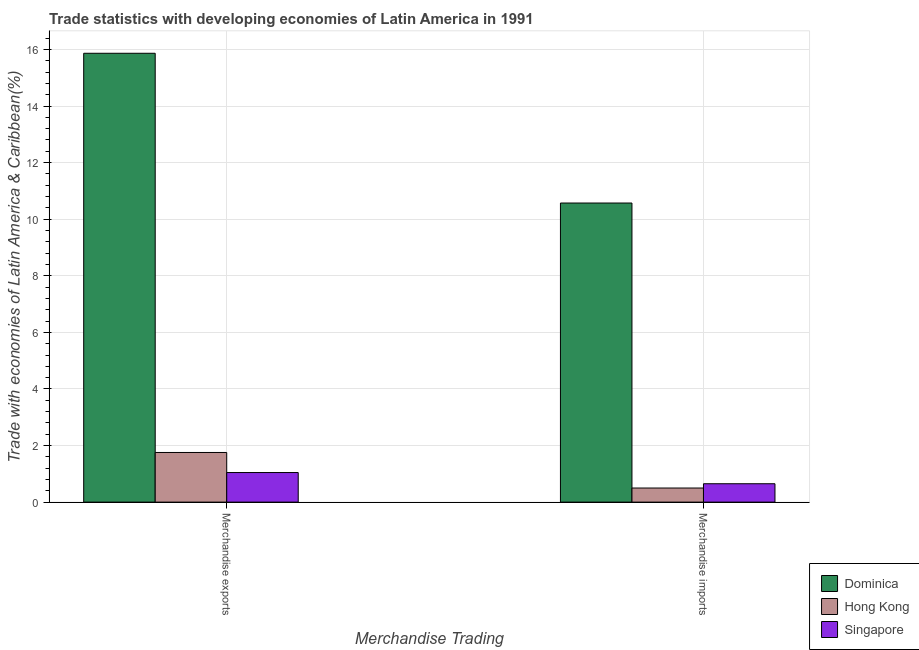How many different coloured bars are there?
Your answer should be very brief. 3. How many groups of bars are there?
Make the answer very short. 2. Are the number of bars per tick equal to the number of legend labels?
Make the answer very short. Yes. Are the number of bars on each tick of the X-axis equal?
Provide a succinct answer. Yes. How many bars are there on the 1st tick from the right?
Ensure brevity in your answer.  3. What is the merchandise exports in Dominica?
Your response must be concise. 15.86. Across all countries, what is the maximum merchandise imports?
Provide a short and direct response. 10.57. Across all countries, what is the minimum merchandise exports?
Your answer should be compact. 1.05. In which country was the merchandise imports maximum?
Provide a short and direct response. Dominica. In which country was the merchandise imports minimum?
Keep it short and to the point. Hong Kong. What is the total merchandise imports in the graph?
Offer a terse response. 11.72. What is the difference between the merchandise imports in Singapore and that in Dominica?
Provide a succinct answer. -9.92. What is the difference between the merchandise exports in Hong Kong and the merchandise imports in Dominica?
Your response must be concise. -8.82. What is the average merchandise exports per country?
Offer a very short reply. 6.22. What is the difference between the merchandise exports and merchandise imports in Singapore?
Your response must be concise. 0.4. What is the ratio of the merchandise imports in Singapore to that in Hong Kong?
Provide a short and direct response. 1.3. Is the merchandise imports in Dominica less than that in Hong Kong?
Offer a terse response. No. What does the 3rd bar from the left in Merchandise exports represents?
Keep it short and to the point. Singapore. What does the 1st bar from the right in Merchandise exports represents?
Offer a very short reply. Singapore. What is the difference between two consecutive major ticks on the Y-axis?
Provide a short and direct response. 2. Does the graph contain any zero values?
Your answer should be compact. No. Does the graph contain grids?
Offer a terse response. Yes. How many legend labels are there?
Ensure brevity in your answer.  3. What is the title of the graph?
Provide a short and direct response. Trade statistics with developing economies of Latin America in 1991. Does "Seychelles" appear as one of the legend labels in the graph?
Offer a terse response. No. What is the label or title of the X-axis?
Offer a terse response. Merchandise Trading. What is the label or title of the Y-axis?
Offer a very short reply. Trade with economies of Latin America & Caribbean(%). What is the Trade with economies of Latin America & Caribbean(%) of Dominica in Merchandise exports?
Give a very brief answer. 15.86. What is the Trade with economies of Latin America & Caribbean(%) of Hong Kong in Merchandise exports?
Ensure brevity in your answer.  1.76. What is the Trade with economies of Latin America & Caribbean(%) in Singapore in Merchandise exports?
Provide a short and direct response. 1.05. What is the Trade with economies of Latin America & Caribbean(%) of Dominica in Merchandise imports?
Your answer should be compact. 10.57. What is the Trade with economies of Latin America & Caribbean(%) in Hong Kong in Merchandise imports?
Your answer should be very brief. 0.5. What is the Trade with economies of Latin America & Caribbean(%) in Singapore in Merchandise imports?
Your answer should be compact. 0.65. Across all Merchandise Trading, what is the maximum Trade with economies of Latin America & Caribbean(%) of Dominica?
Make the answer very short. 15.86. Across all Merchandise Trading, what is the maximum Trade with economies of Latin America & Caribbean(%) of Hong Kong?
Ensure brevity in your answer.  1.76. Across all Merchandise Trading, what is the maximum Trade with economies of Latin America & Caribbean(%) in Singapore?
Ensure brevity in your answer.  1.05. Across all Merchandise Trading, what is the minimum Trade with economies of Latin America & Caribbean(%) in Dominica?
Provide a succinct answer. 10.57. Across all Merchandise Trading, what is the minimum Trade with economies of Latin America & Caribbean(%) of Hong Kong?
Your answer should be very brief. 0.5. Across all Merchandise Trading, what is the minimum Trade with economies of Latin America & Caribbean(%) in Singapore?
Your answer should be compact. 0.65. What is the total Trade with economies of Latin America & Caribbean(%) of Dominica in the graph?
Your response must be concise. 26.44. What is the total Trade with economies of Latin America & Caribbean(%) of Hong Kong in the graph?
Make the answer very short. 2.25. What is the total Trade with economies of Latin America & Caribbean(%) of Singapore in the graph?
Your answer should be very brief. 1.7. What is the difference between the Trade with economies of Latin America & Caribbean(%) of Dominica in Merchandise exports and that in Merchandise imports?
Provide a short and direct response. 5.29. What is the difference between the Trade with economies of Latin America & Caribbean(%) in Hong Kong in Merchandise exports and that in Merchandise imports?
Keep it short and to the point. 1.26. What is the difference between the Trade with economies of Latin America & Caribbean(%) in Singapore in Merchandise exports and that in Merchandise imports?
Offer a very short reply. 0.4. What is the difference between the Trade with economies of Latin America & Caribbean(%) in Dominica in Merchandise exports and the Trade with economies of Latin America & Caribbean(%) in Hong Kong in Merchandise imports?
Your response must be concise. 15.37. What is the difference between the Trade with economies of Latin America & Caribbean(%) of Dominica in Merchandise exports and the Trade with economies of Latin America & Caribbean(%) of Singapore in Merchandise imports?
Your answer should be very brief. 15.21. What is the difference between the Trade with economies of Latin America & Caribbean(%) in Hong Kong in Merchandise exports and the Trade with economies of Latin America & Caribbean(%) in Singapore in Merchandise imports?
Offer a very short reply. 1.11. What is the average Trade with economies of Latin America & Caribbean(%) in Dominica per Merchandise Trading?
Give a very brief answer. 13.22. What is the average Trade with economies of Latin America & Caribbean(%) in Hong Kong per Merchandise Trading?
Your answer should be very brief. 1.13. What is the average Trade with economies of Latin America & Caribbean(%) in Singapore per Merchandise Trading?
Your answer should be compact. 0.85. What is the difference between the Trade with economies of Latin America & Caribbean(%) in Dominica and Trade with economies of Latin America & Caribbean(%) in Hong Kong in Merchandise exports?
Offer a very short reply. 14.11. What is the difference between the Trade with economies of Latin America & Caribbean(%) in Dominica and Trade with economies of Latin America & Caribbean(%) in Singapore in Merchandise exports?
Your answer should be compact. 14.82. What is the difference between the Trade with economies of Latin America & Caribbean(%) of Hong Kong and Trade with economies of Latin America & Caribbean(%) of Singapore in Merchandise exports?
Provide a succinct answer. 0.71. What is the difference between the Trade with economies of Latin America & Caribbean(%) in Dominica and Trade with economies of Latin America & Caribbean(%) in Hong Kong in Merchandise imports?
Your answer should be compact. 10.07. What is the difference between the Trade with economies of Latin America & Caribbean(%) of Dominica and Trade with economies of Latin America & Caribbean(%) of Singapore in Merchandise imports?
Offer a very short reply. 9.92. What is the difference between the Trade with economies of Latin America & Caribbean(%) in Hong Kong and Trade with economies of Latin America & Caribbean(%) in Singapore in Merchandise imports?
Your answer should be very brief. -0.15. What is the ratio of the Trade with economies of Latin America & Caribbean(%) in Dominica in Merchandise exports to that in Merchandise imports?
Your response must be concise. 1.5. What is the ratio of the Trade with economies of Latin America & Caribbean(%) in Hong Kong in Merchandise exports to that in Merchandise imports?
Offer a very short reply. 3.52. What is the ratio of the Trade with economies of Latin America & Caribbean(%) in Singapore in Merchandise exports to that in Merchandise imports?
Your response must be concise. 1.61. What is the difference between the highest and the second highest Trade with economies of Latin America & Caribbean(%) in Dominica?
Give a very brief answer. 5.29. What is the difference between the highest and the second highest Trade with economies of Latin America & Caribbean(%) of Hong Kong?
Ensure brevity in your answer.  1.26. What is the difference between the highest and the second highest Trade with economies of Latin America & Caribbean(%) in Singapore?
Provide a short and direct response. 0.4. What is the difference between the highest and the lowest Trade with economies of Latin America & Caribbean(%) in Dominica?
Ensure brevity in your answer.  5.29. What is the difference between the highest and the lowest Trade with economies of Latin America & Caribbean(%) in Hong Kong?
Provide a short and direct response. 1.26. What is the difference between the highest and the lowest Trade with economies of Latin America & Caribbean(%) of Singapore?
Keep it short and to the point. 0.4. 